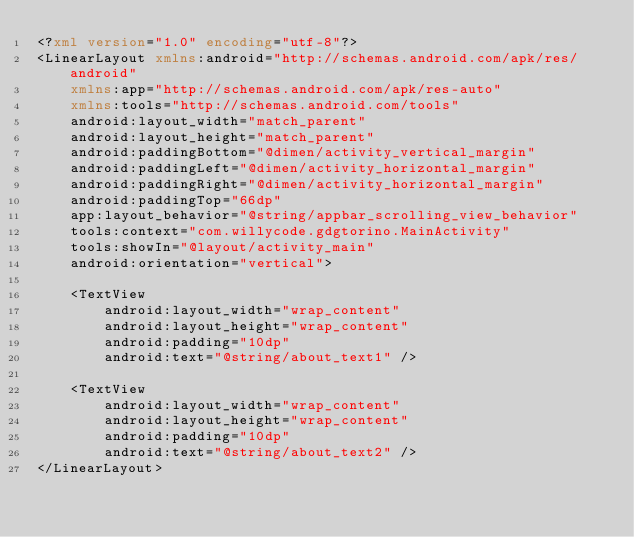Convert code to text. <code><loc_0><loc_0><loc_500><loc_500><_XML_><?xml version="1.0" encoding="utf-8"?>
<LinearLayout xmlns:android="http://schemas.android.com/apk/res/android"
    xmlns:app="http://schemas.android.com/apk/res-auto"
    xmlns:tools="http://schemas.android.com/tools"
    android:layout_width="match_parent"
    android:layout_height="match_parent"
    android:paddingBottom="@dimen/activity_vertical_margin"
    android:paddingLeft="@dimen/activity_horizontal_margin"
    android:paddingRight="@dimen/activity_horizontal_margin"
    android:paddingTop="66dp"
    app:layout_behavior="@string/appbar_scrolling_view_behavior"
    tools:context="com.willycode.gdgtorino.MainActivity"
    tools:showIn="@layout/activity_main"
    android:orientation="vertical">

    <TextView
        android:layout_width="wrap_content"
        android:layout_height="wrap_content"
        android:padding="10dp"
        android:text="@string/about_text1" />

    <TextView
        android:layout_width="wrap_content"
        android:layout_height="wrap_content"
        android:padding="10dp"
        android:text="@string/about_text2" />
</LinearLayout>
</code> 